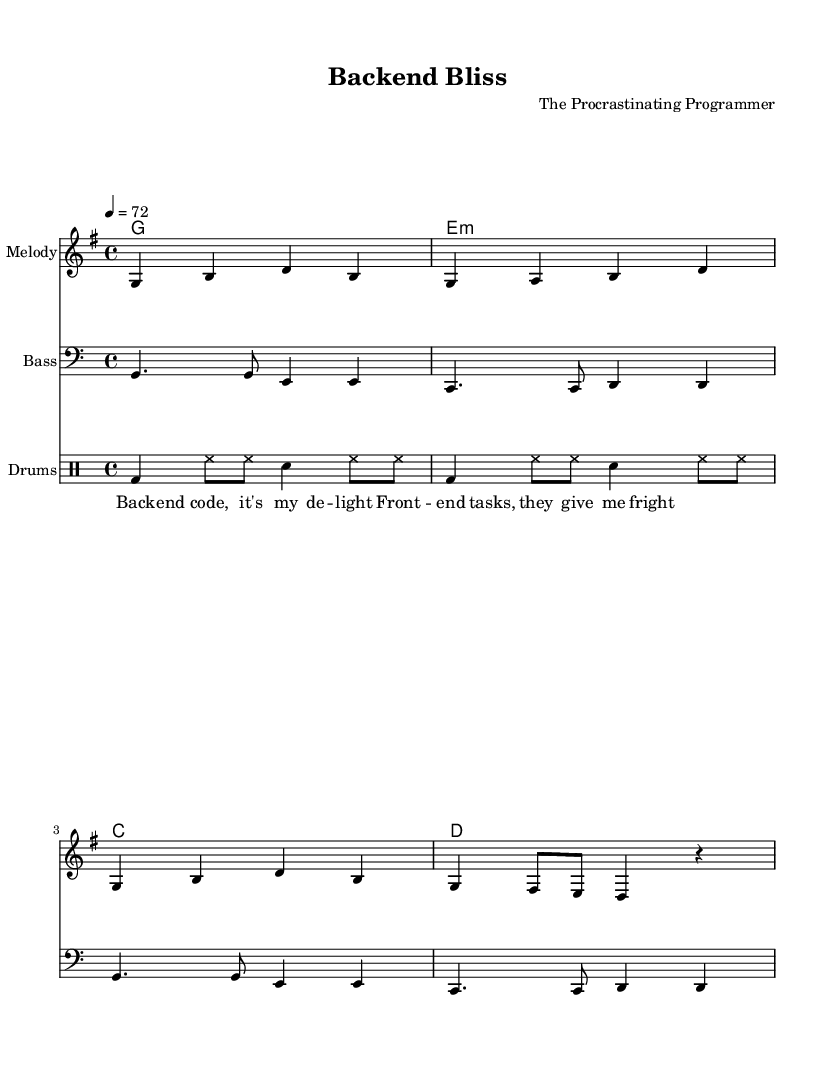What is the key signature of this music? The key signature is G major, which has one sharp (F#). This can be identified by looking at the key signature section at the beginning of the staff, where a single sharp is marked.
Answer: G major What is the time signature of the piece? The time signature is four-four (4/4), indicated at the beginning of the score right after the key signature. This means there are four beats in each measure, and the quarter note gets one beat.
Answer: 4/4 What is the tempo marking for the music? The tempo marking is 72 beats per minute, as noted in the tempo section at the beginning of the score. This tells the performer to play at a moderate pace, which is typical for laid-back reggae tunes.
Answer: 72 How many measures are in the melody? There are eight measures in the melody section. This can be counted by identifying the bar lines that separate each measure in the melody staff. Each group of notes between the bar lines corresponds to one measure.
Answer: 8 What kind of drums are specified in the drum patterns? The drum patterns specify bass drum and snare drum, as indicated by the symbols used in the drum staff. The bass drum (bd) is sometimes notated with "bd" while the snare (sn) is labeled "sn," indicating which drum to play.
Answer: Bass drum and snare drum What is the primary harmonic progression used in this piece? The primary harmonic progression is G, E minor, C, D. This can be deduced by analyzing the chord symbols written above the staff in the harmonies section, which indicate the chords played alongside the melody.
Answer: G, E minor, C, D What lyrical theme is expressed in the lyrics? The lyrics express a theme of backend coding versus frontend tasks, highlighting a preference or reluctance for frontend chores. This can be understood by reading the lyrics directly as they convey a narrative relevant to the composer's intention.
Answer: Backend coding vs frontend tasks 